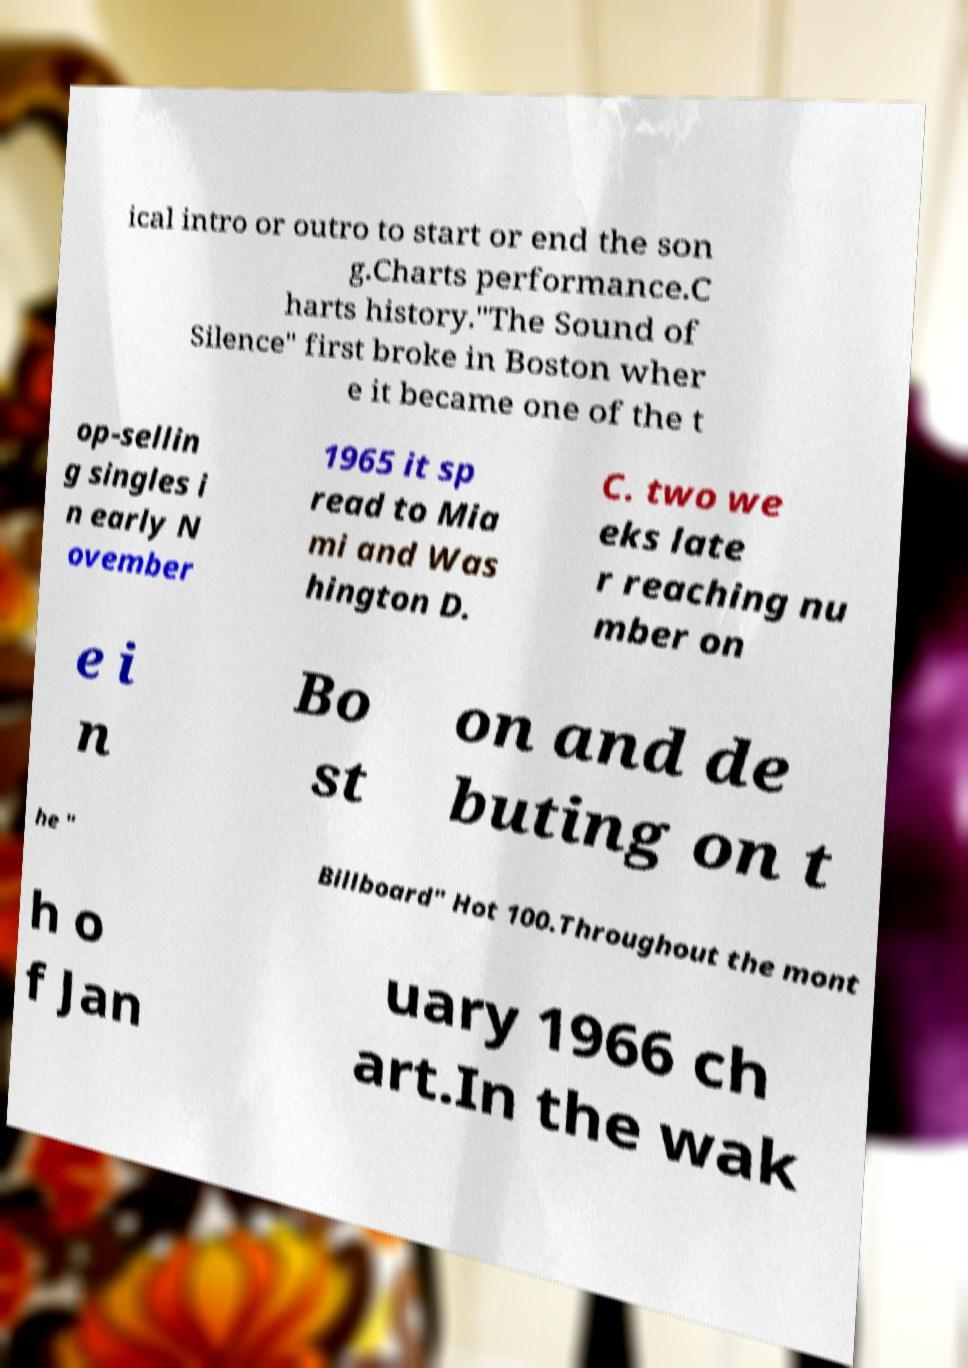What messages or text are displayed in this image? I need them in a readable, typed format. ical intro or outro to start or end the son g.Charts performance.C harts history."The Sound of Silence" first broke in Boston wher e it became one of the t op-sellin g singles i n early N ovember 1965 it sp read to Mia mi and Was hington D. C. two we eks late r reaching nu mber on e i n Bo st on and de buting on t he " Billboard" Hot 100.Throughout the mont h o f Jan uary 1966 ch art.In the wak 